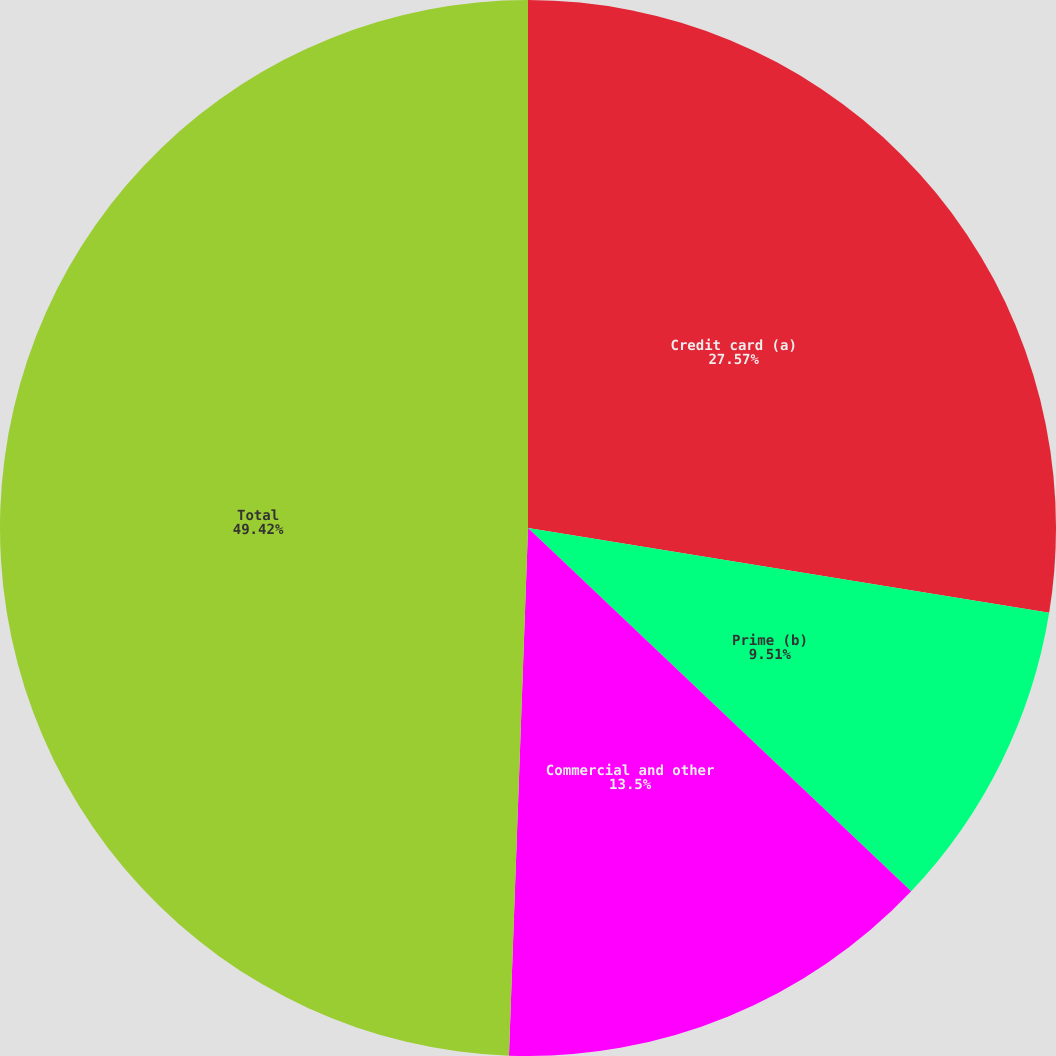Convert chart. <chart><loc_0><loc_0><loc_500><loc_500><pie_chart><fcel>Credit card (a)<fcel>Prime (b)<fcel>Commercial and other<fcel>Total<nl><fcel>27.57%<fcel>9.51%<fcel>13.5%<fcel>49.43%<nl></chart> 